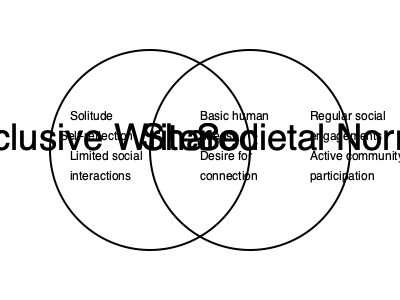Analyze the Venn diagram comparing a reclusive writer's lifestyle to societal norms. Which element in the "Shared" section represents the writer's motivation to share their experiences with the world? To answer this question, let's break down the Venn diagram and analyze its components:

1. The left circle represents the reclusive writer's lifestyle, including:
   - Solitude
   - Self-reflection
   - Limited social interactions

2. The right circle represents societal norms, including:
   - Regular social engagements
   - Active community participation

3. The overlapping section, labeled "Shared," represents common elements between the reclusive writer and societal norms:
   - Basic human needs
   - Desire for connection

Now, let's consider the writer's motivation to share their experiences with the world:

1. The question asks about an element in the "Shared" section that represents this motivation.
2. Among the shared elements, "Desire for connection" aligns most closely with the writer's goal of sharing their experiences.
3. This desire for connection, despite the writer's reclusive lifestyle, drives them to reach out to the world through their writing.

Therefore, the element in the "Shared" section that best represents the writer's motivation to share their experiences is the "Desire for connection."
Answer: Desire for connection 